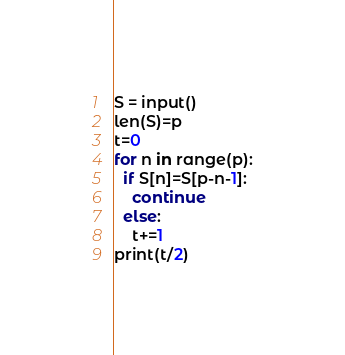Convert code to text. <code><loc_0><loc_0><loc_500><loc_500><_Python_>S = input()
len(S)=p
t=0
for n in range(p):
  if S[n]=S[p-n-1]:
    continue
  else:
    t+=1
print(t/2)</code> 